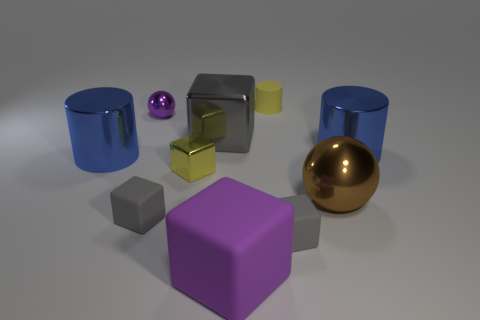What number of large spheres have the same material as the big purple cube?
Offer a terse response. 0. What is the gray block on the right side of the gray shiny block made of?
Your response must be concise. Rubber. There is a small yellow thing that is in front of the big blue thing that is behind the big blue cylinder to the left of the yellow rubber cylinder; what is its shape?
Give a very brief answer. Cube. There is a small block that is on the right side of the purple matte thing; is its color the same as the rubber thing behind the big gray metal block?
Offer a terse response. No. Is the number of small purple spheres in front of the tiny yellow rubber thing less than the number of big blue shiny cylinders in front of the small yellow metal block?
Your answer should be compact. No. Are there any other things that have the same shape as the big gray shiny object?
Your answer should be compact. Yes. There is another shiny thing that is the same shape as the large gray metallic object; what is its color?
Provide a short and direct response. Yellow. Does the large rubber object have the same shape as the blue object that is left of the big purple block?
Provide a succinct answer. No. How many objects are either big metal things that are right of the large purple matte block or gray things to the left of the big metal block?
Provide a short and direct response. 3. What is the material of the purple block?
Ensure brevity in your answer.  Rubber. 